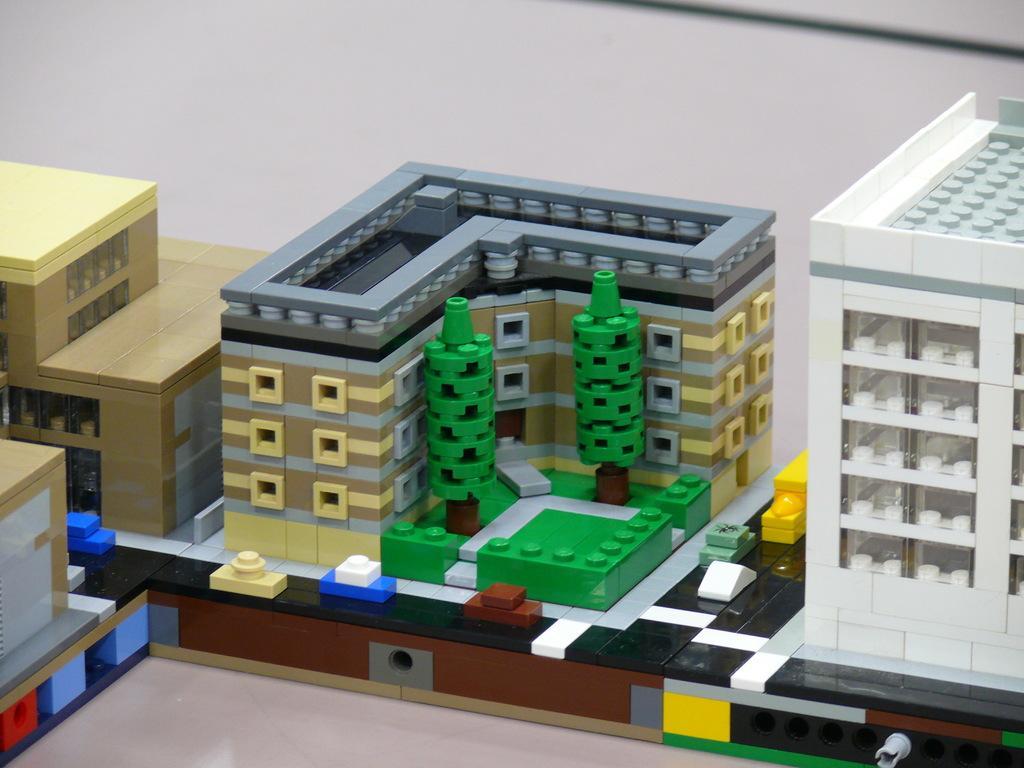Describe this image in one or two sentences. In this image, we can see some toy buildings. 